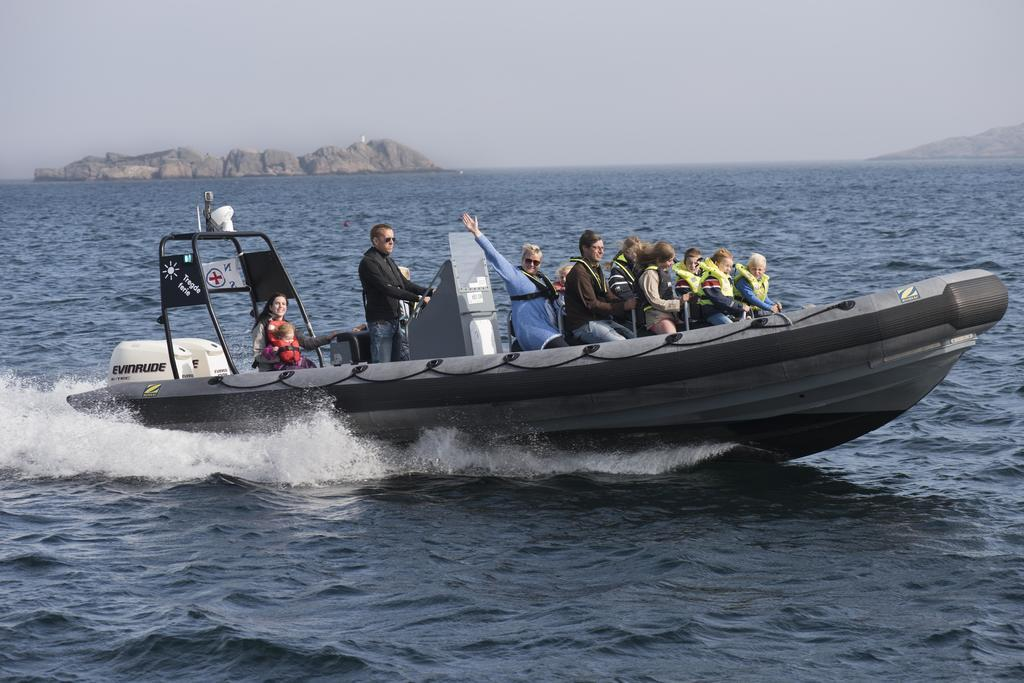What is the main subject of the image? The main subject of the image is persons on a boat. What is the boat doing in the image? The boat is floating on water in the image. What can be seen in the top left corner of the image? There is a hill in the top left of the image. What is visible at the top of the image? The sky is visible at the top of the image. What type of thing is bursting in the image? There is no thing bursting in the image. 